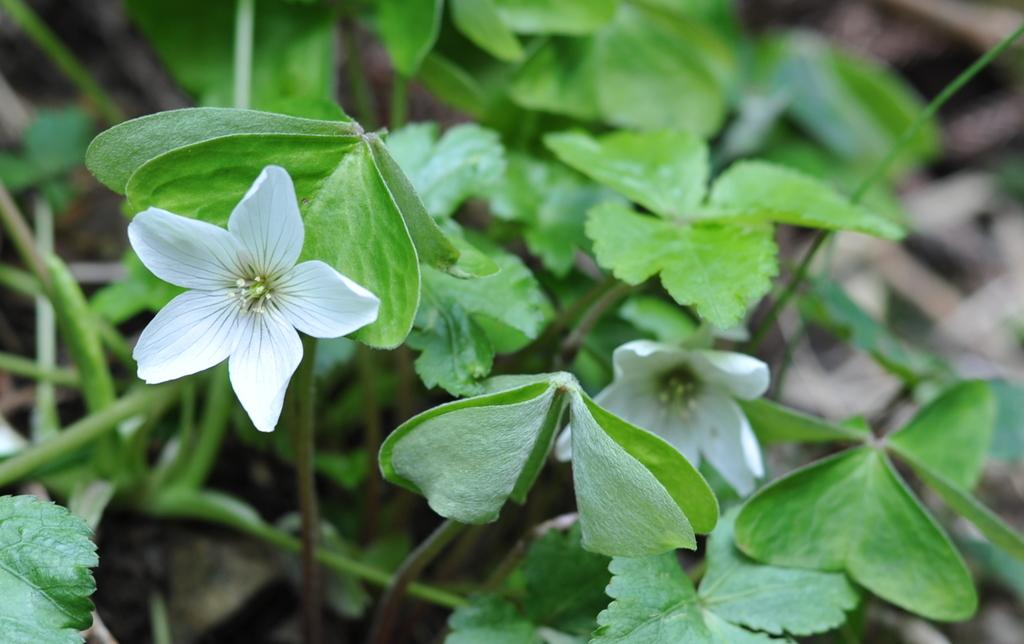What types of plants are visible in the image? There are plants with flowers and plants with leaves in the image. Can you describe the plants in the background of the image? The background of the image includes plants on the land. What type of star can be seen shining brightly in the image? There is no star visible in the image; it features plants with flowers and leaves. What kind of cable is connected to the plants in the image? There is no cable connected to the plants in the image; it only shows plants with flowers and leaves. 